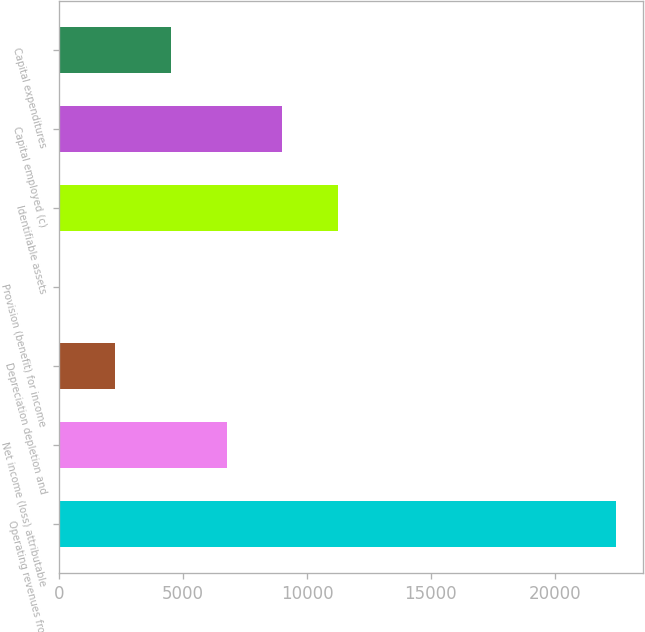Convert chart to OTSL. <chart><loc_0><loc_0><loc_500><loc_500><bar_chart><fcel>Operating revenues from<fcel>Net income (loss) attributable<fcel>Depreciation depletion and<fcel>Provision (benefit) for income<fcel>Identifiable assets<fcel>Capital employed (c)<fcel>Capital expenditures<nl><fcel>22464<fcel>6756<fcel>2268<fcel>24<fcel>11244<fcel>9000<fcel>4512<nl></chart> 